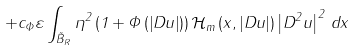Convert formula to latex. <formula><loc_0><loc_0><loc_500><loc_500>+ c _ { \Phi } \varepsilon \int _ { \tilde { B } _ { R } } \eta ^ { 2 } \left ( 1 + \Phi \left ( \left | D u \right | \right ) \right ) \mathcal { H } _ { m } \left ( x , \left | D u \right | \right ) \left | D ^ { 2 } u \right | ^ { 2 } \, d x</formula> 